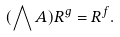<formula> <loc_0><loc_0><loc_500><loc_500>( \bigwedge A ) R ^ { g } = R ^ { f } .</formula> 